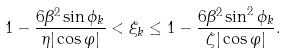<formula> <loc_0><loc_0><loc_500><loc_500>1 - \frac { 6 \beta ^ { 2 } \sin \phi _ { k } } { \eta | \cos \varphi | } < \xi _ { k } \leq 1 - \frac { 6 \beta ^ { 2 } \sin ^ { 2 } \phi _ { k } } { \zeta | \cos \varphi | } .</formula> 